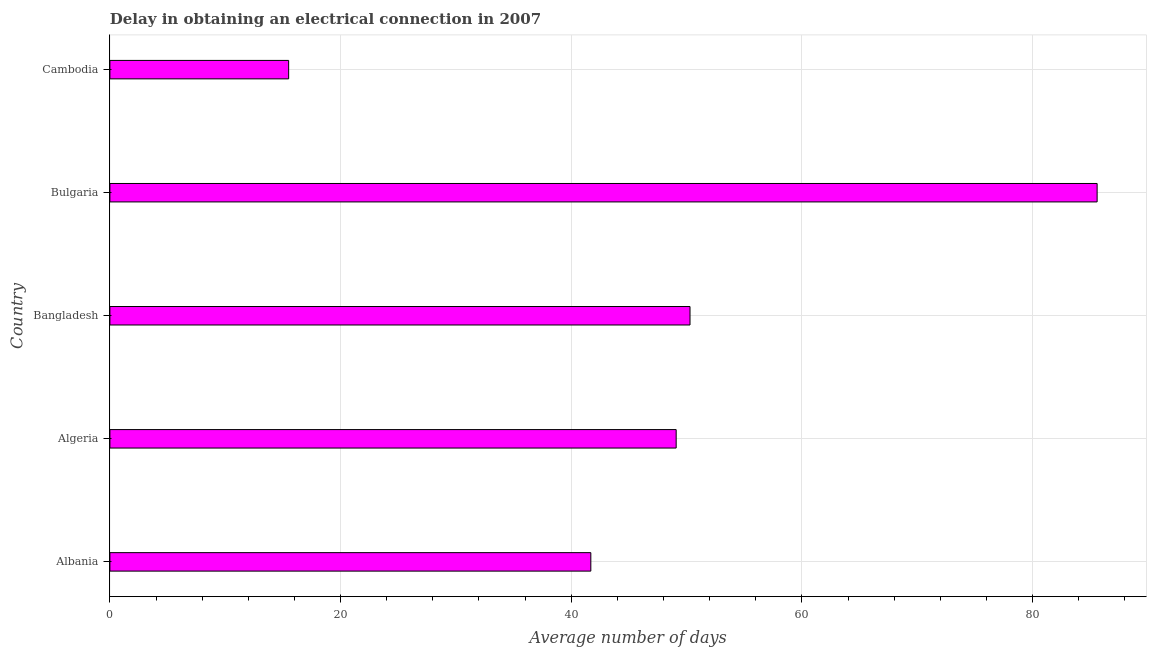What is the title of the graph?
Give a very brief answer. Delay in obtaining an electrical connection in 2007. What is the label or title of the X-axis?
Offer a very short reply. Average number of days. What is the label or title of the Y-axis?
Offer a very short reply. Country. Across all countries, what is the maximum dalay in electrical connection?
Keep it short and to the point. 85.6. Across all countries, what is the minimum dalay in electrical connection?
Provide a succinct answer. 15.5. In which country was the dalay in electrical connection minimum?
Your answer should be compact. Cambodia. What is the sum of the dalay in electrical connection?
Provide a succinct answer. 242.2. What is the difference between the dalay in electrical connection in Bangladesh and Bulgaria?
Offer a terse response. -35.3. What is the average dalay in electrical connection per country?
Provide a succinct answer. 48.44. What is the median dalay in electrical connection?
Give a very brief answer. 49.1. In how many countries, is the dalay in electrical connection greater than 44 days?
Provide a short and direct response. 3. What is the ratio of the dalay in electrical connection in Algeria to that in Cambodia?
Provide a succinct answer. 3.17. Is the dalay in electrical connection in Albania less than that in Bangladesh?
Provide a succinct answer. Yes. Is the difference between the dalay in electrical connection in Albania and Bangladesh greater than the difference between any two countries?
Provide a short and direct response. No. What is the difference between the highest and the second highest dalay in electrical connection?
Ensure brevity in your answer.  35.3. What is the difference between the highest and the lowest dalay in electrical connection?
Give a very brief answer. 70.1. Are the values on the major ticks of X-axis written in scientific E-notation?
Offer a very short reply. No. What is the Average number of days of Albania?
Provide a short and direct response. 41.7. What is the Average number of days in Algeria?
Ensure brevity in your answer.  49.1. What is the Average number of days of Bangladesh?
Your response must be concise. 50.3. What is the Average number of days of Bulgaria?
Keep it short and to the point. 85.6. What is the difference between the Average number of days in Albania and Algeria?
Your answer should be very brief. -7.4. What is the difference between the Average number of days in Albania and Bulgaria?
Provide a succinct answer. -43.9. What is the difference between the Average number of days in Albania and Cambodia?
Give a very brief answer. 26.2. What is the difference between the Average number of days in Algeria and Bulgaria?
Your answer should be very brief. -36.5. What is the difference between the Average number of days in Algeria and Cambodia?
Your response must be concise. 33.6. What is the difference between the Average number of days in Bangladesh and Bulgaria?
Give a very brief answer. -35.3. What is the difference between the Average number of days in Bangladesh and Cambodia?
Your answer should be compact. 34.8. What is the difference between the Average number of days in Bulgaria and Cambodia?
Keep it short and to the point. 70.1. What is the ratio of the Average number of days in Albania to that in Algeria?
Offer a very short reply. 0.85. What is the ratio of the Average number of days in Albania to that in Bangladesh?
Provide a short and direct response. 0.83. What is the ratio of the Average number of days in Albania to that in Bulgaria?
Provide a succinct answer. 0.49. What is the ratio of the Average number of days in Albania to that in Cambodia?
Provide a succinct answer. 2.69. What is the ratio of the Average number of days in Algeria to that in Bangladesh?
Provide a short and direct response. 0.98. What is the ratio of the Average number of days in Algeria to that in Bulgaria?
Your answer should be compact. 0.57. What is the ratio of the Average number of days in Algeria to that in Cambodia?
Ensure brevity in your answer.  3.17. What is the ratio of the Average number of days in Bangladesh to that in Bulgaria?
Your response must be concise. 0.59. What is the ratio of the Average number of days in Bangladesh to that in Cambodia?
Your response must be concise. 3.25. What is the ratio of the Average number of days in Bulgaria to that in Cambodia?
Keep it short and to the point. 5.52. 